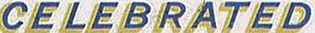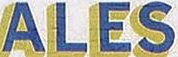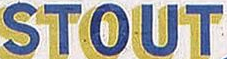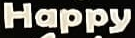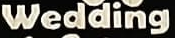Read the text from these images in sequence, separated by a semicolon. CELEBRATED; ALES; STOUT; Happy; Wedding 